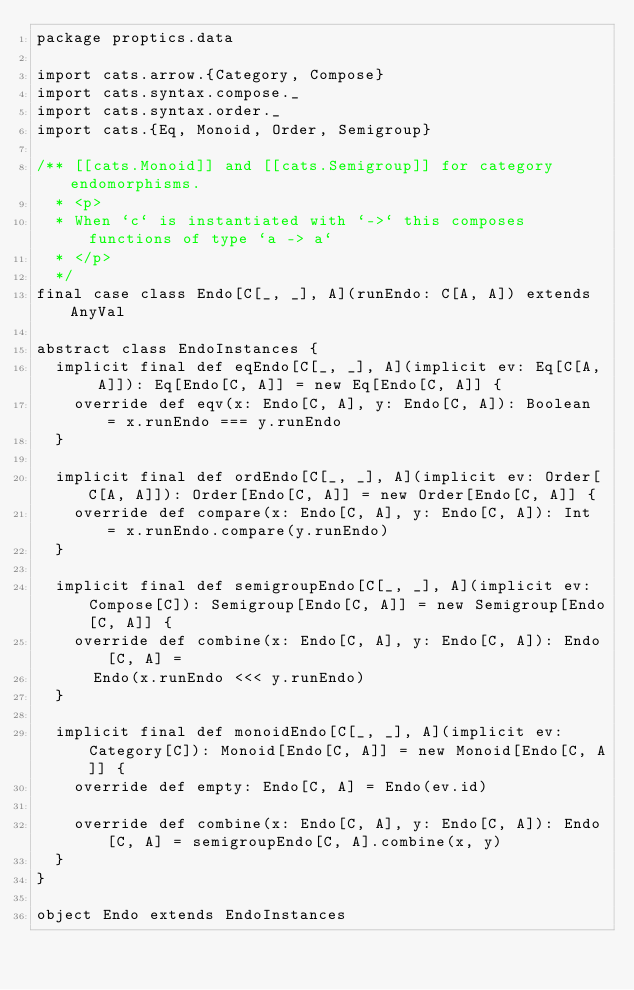<code> <loc_0><loc_0><loc_500><loc_500><_Scala_>package proptics.data

import cats.arrow.{Category, Compose}
import cats.syntax.compose._
import cats.syntax.order._
import cats.{Eq, Monoid, Order, Semigroup}

/** [[cats.Monoid]] and [[cats.Semigroup]] for category endomorphisms.
  * <p>
  * When `c` is instantiated with `->` this composes functions of type `a -> a`
  * </p>
  */
final case class Endo[C[_, _], A](runEndo: C[A, A]) extends AnyVal

abstract class EndoInstances {
  implicit final def eqEndo[C[_, _], A](implicit ev: Eq[C[A, A]]): Eq[Endo[C, A]] = new Eq[Endo[C, A]] {
    override def eqv(x: Endo[C, A], y: Endo[C, A]): Boolean = x.runEndo === y.runEndo
  }

  implicit final def ordEndo[C[_, _], A](implicit ev: Order[C[A, A]]): Order[Endo[C, A]] = new Order[Endo[C, A]] {
    override def compare(x: Endo[C, A], y: Endo[C, A]): Int = x.runEndo.compare(y.runEndo)
  }

  implicit final def semigroupEndo[C[_, _], A](implicit ev: Compose[C]): Semigroup[Endo[C, A]] = new Semigroup[Endo[C, A]] {
    override def combine(x: Endo[C, A], y: Endo[C, A]): Endo[C, A] =
      Endo(x.runEndo <<< y.runEndo)
  }

  implicit final def monoidEndo[C[_, _], A](implicit ev: Category[C]): Monoid[Endo[C, A]] = new Monoid[Endo[C, A]] {
    override def empty: Endo[C, A] = Endo(ev.id)

    override def combine(x: Endo[C, A], y: Endo[C, A]): Endo[C, A] = semigroupEndo[C, A].combine(x, y)
  }
}

object Endo extends EndoInstances
</code> 